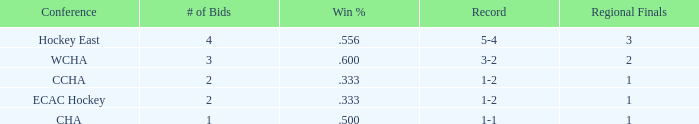What is the average Regional Finals score when the record is 3-2 and there are more than 3 bids? None. Help me parse the entirety of this table. {'header': ['Conference', '# of Bids', 'Win %', 'Record', 'Regional Finals'], 'rows': [['Hockey East', '4', '.556', '5-4', '3'], ['WCHA', '3', '.600', '3-2', '2'], ['CCHA', '2', '.333', '1-2', '1'], ['ECAC Hockey', '2', '.333', '1-2', '1'], ['CHA', '1', '.500', '1-1', '1']]} 